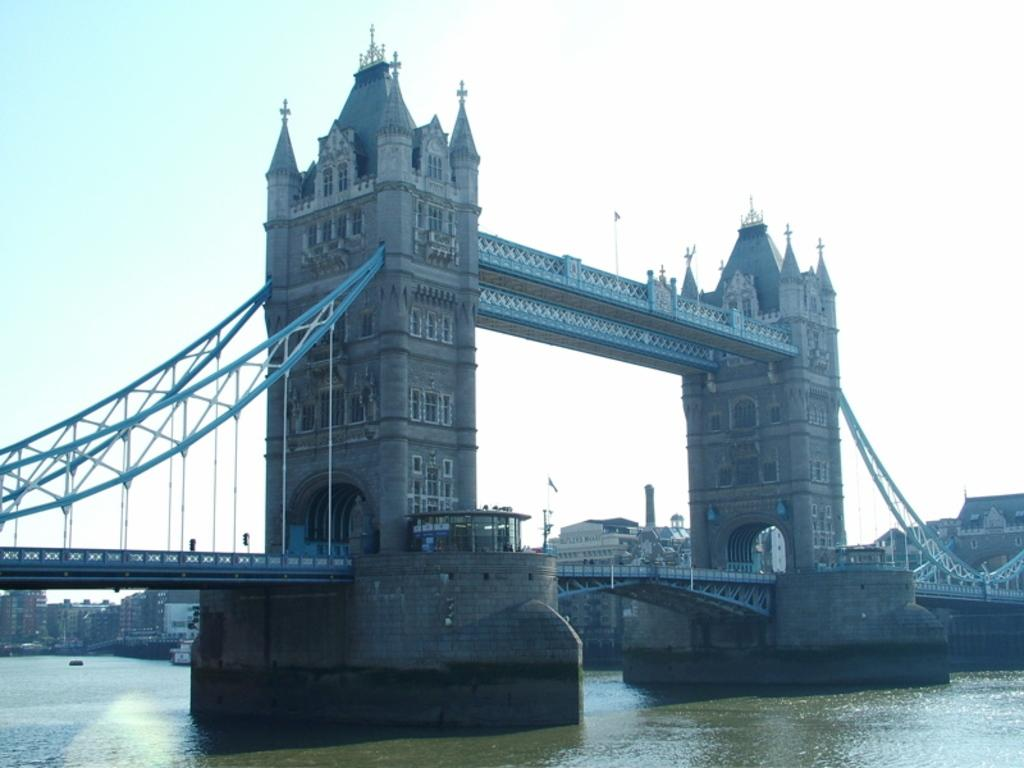What body of water is present in the image? There is a lake in the picture. What structure can be seen on the lake? There is a bridge on the lake. Are there any man-made structures visible near the lake? Yes, there are buildings visible near the lake. What type of flock is flying over the lake in the image? There is no flock of birds or any other animals visible in the image. 